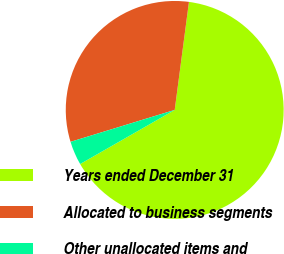Convert chart to OTSL. <chart><loc_0><loc_0><loc_500><loc_500><pie_chart><fcel>Years ended December 31<fcel>Allocated to business segments<fcel>Other unallocated items and<nl><fcel>64.64%<fcel>31.82%<fcel>3.54%<nl></chart> 